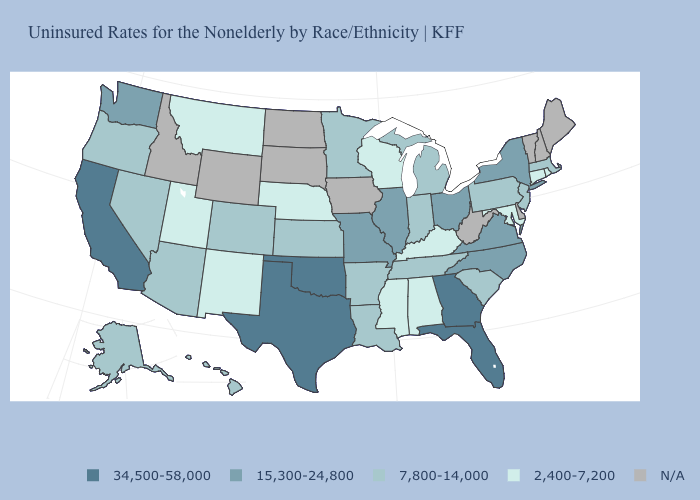What is the highest value in states that border West Virginia?
Short answer required. 15,300-24,800. Name the states that have a value in the range 7,800-14,000?
Be succinct. Alaska, Arizona, Arkansas, Colorado, Hawaii, Indiana, Kansas, Louisiana, Massachusetts, Michigan, Minnesota, Nevada, New Jersey, Oregon, Pennsylvania, South Carolina, Tennessee. Name the states that have a value in the range 7,800-14,000?
Short answer required. Alaska, Arizona, Arkansas, Colorado, Hawaii, Indiana, Kansas, Louisiana, Massachusetts, Michigan, Minnesota, Nevada, New Jersey, Oregon, Pennsylvania, South Carolina, Tennessee. Among the states that border New Jersey , which have the lowest value?
Concise answer only. Pennsylvania. What is the highest value in the South ?
Be succinct. 34,500-58,000. Does Massachusetts have the lowest value in the Northeast?
Be succinct. No. Which states have the lowest value in the USA?
Give a very brief answer. Alabama, Connecticut, Kentucky, Maryland, Mississippi, Montana, Nebraska, New Mexico, Rhode Island, Utah, Wisconsin. What is the value of South Carolina?
Concise answer only. 7,800-14,000. Which states hav the highest value in the West?
Write a very short answer. California. Name the states that have a value in the range 34,500-58,000?
Short answer required. California, Florida, Georgia, Oklahoma, Texas. What is the highest value in states that border North Dakota?
Be succinct. 7,800-14,000. Does Texas have the highest value in the USA?
Write a very short answer. Yes. What is the value of Missouri?
Quick response, please. 15,300-24,800. 